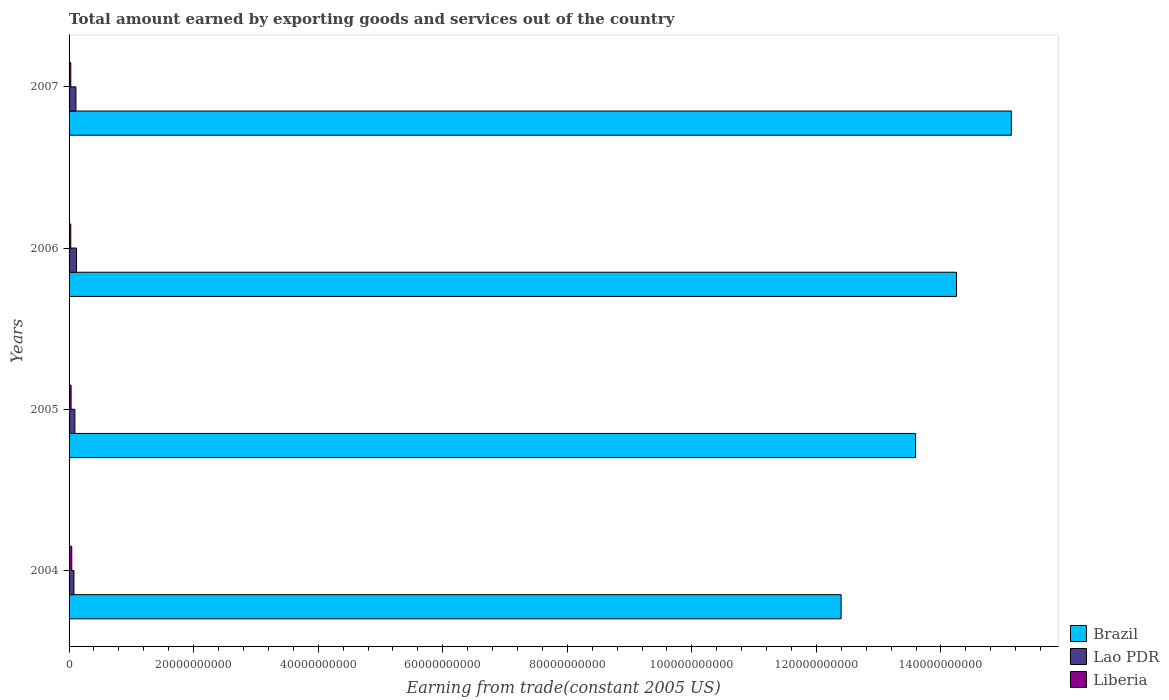How many groups of bars are there?
Your answer should be compact. 4. Are the number of bars per tick equal to the number of legend labels?
Offer a very short reply. Yes. Are the number of bars on each tick of the Y-axis equal?
Your answer should be very brief. Yes. How many bars are there on the 3rd tick from the top?
Offer a very short reply. 3. How many bars are there on the 3rd tick from the bottom?
Your answer should be compact. 3. In how many cases, is the number of bars for a given year not equal to the number of legend labels?
Your answer should be very brief. 0. What is the total amount earned by exporting goods and services in Liberia in 2006?
Offer a terse response. 2.71e+08. Across all years, what is the maximum total amount earned by exporting goods and services in Liberia?
Your answer should be very brief. 4.31e+08. Across all years, what is the minimum total amount earned by exporting goods and services in Brazil?
Your answer should be very brief. 1.24e+11. In which year was the total amount earned by exporting goods and services in Lao PDR maximum?
Your answer should be compact. 2006. In which year was the total amount earned by exporting goods and services in Lao PDR minimum?
Your answer should be very brief. 2004. What is the total total amount earned by exporting goods and services in Liberia in the graph?
Keep it short and to the point. 1.30e+09. What is the difference between the total amount earned by exporting goods and services in Lao PDR in 2004 and that in 2005?
Give a very brief answer. -1.54e+08. What is the difference between the total amount earned by exporting goods and services in Brazil in 2006 and the total amount earned by exporting goods and services in Liberia in 2007?
Keep it short and to the point. 1.42e+11. What is the average total amount earned by exporting goods and services in Lao PDR per year?
Ensure brevity in your answer.  1.00e+09. In the year 2007, what is the difference between the total amount earned by exporting goods and services in Brazil and total amount earned by exporting goods and services in Liberia?
Keep it short and to the point. 1.51e+11. What is the ratio of the total amount earned by exporting goods and services in Brazil in 2005 to that in 2007?
Provide a succinct answer. 0.9. Is the difference between the total amount earned by exporting goods and services in Brazil in 2004 and 2006 greater than the difference between the total amount earned by exporting goods and services in Liberia in 2004 and 2006?
Ensure brevity in your answer.  No. What is the difference between the highest and the second highest total amount earned by exporting goods and services in Brazil?
Your answer should be compact. 8.80e+09. What is the difference between the highest and the lowest total amount earned by exporting goods and services in Brazil?
Offer a very short reply. 2.73e+1. Is the sum of the total amount earned by exporting goods and services in Liberia in 2004 and 2005 greater than the maximum total amount earned by exporting goods and services in Brazil across all years?
Your answer should be compact. No. What does the 2nd bar from the top in 2007 represents?
Keep it short and to the point. Lao PDR. How many bars are there?
Your answer should be very brief. 12. Are all the bars in the graph horizontal?
Offer a very short reply. Yes. What is the difference between two consecutive major ticks on the X-axis?
Give a very brief answer. 2.00e+1. Does the graph contain any zero values?
Ensure brevity in your answer.  No. How many legend labels are there?
Your answer should be very brief. 3. What is the title of the graph?
Provide a succinct answer. Total amount earned by exporting goods and services out of the country. What is the label or title of the X-axis?
Make the answer very short. Earning from trade(constant 2005 US). What is the Earning from trade(constant 2005 US) in Brazil in 2004?
Offer a very short reply. 1.24e+11. What is the Earning from trade(constant 2005 US) of Lao PDR in 2004?
Your answer should be compact. 7.80e+08. What is the Earning from trade(constant 2005 US) in Liberia in 2004?
Make the answer very short. 4.31e+08. What is the Earning from trade(constant 2005 US) of Brazil in 2005?
Make the answer very short. 1.36e+11. What is the Earning from trade(constant 2005 US) of Lao PDR in 2005?
Your answer should be compact. 9.34e+08. What is the Earning from trade(constant 2005 US) of Liberia in 2005?
Your answer should be compact. 3.25e+08. What is the Earning from trade(constant 2005 US) of Brazil in 2006?
Your answer should be compact. 1.42e+11. What is the Earning from trade(constant 2005 US) of Lao PDR in 2006?
Give a very brief answer. 1.20e+09. What is the Earning from trade(constant 2005 US) in Liberia in 2006?
Your response must be concise. 2.71e+08. What is the Earning from trade(constant 2005 US) in Brazil in 2007?
Provide a short and direct response. 1.51e+11. What is the Earning from trade(constant 2005 US) of Lao PDR in 2007?
Offer a terse response. 1.10e+09. What is the Earning from trade(constant 2005 US) in Liberia in 2007?
Provide a succinct answer. 2.75e+08. Across all years, what is the maximum Earning from trade(constant 2005 US) in Brazil?
Make the answer very short. 1.51e+11. Across all years, what is the maximum Earning from trade(constant 2005 US) of Lao PDR?
Provide a succinct answer. 1.20e+09. Across all years, what is the maximum Earning from trade(constant 2005 US) of Liberia?
Your answer should be very brief. 4.31e+08. Across all years, what is the minimum Earning from trade(constant 2005 US) of Brazil?
Your answer should be compact. 1.24e+11. Across all years, what is the minimum Earning from trade(constant 2005 US) in Lao PDR?
Ensure brevity in your answer.  7.80e+08. Across all years, what is the minimum Earning from trade(constant 2005 US) of Liberia?
Offer a very short reply. 2.71e+08. What is the total Earning from trade(constant 2005 US) in Brazil in the graph?
Make the answer very short. 5.54e+11. What is the total Earning from trade(constant 2005 US) in Lao PDR in the graph?
Provide a succinct answer. 4.02e+09. What is the total Earning from trade(constant 2005 US) in Liberia in the graph?
Your answer should be very brief. 1.30e+09. What is the difference between the Earning from trade(constant 2005 US) of Brazil in 2004 and that in 2005?
Offer a very short reply. -1.20e+1. What is the difference between the Earning from trade(constant 2005 US) in Lao PDR in 2004 and that in 2005?
Offer a very short reply. -1.54e+08. What is the difference between the Earning from trade(constant 2005 US) in Liberia in 2004 and that in 2005?
Keep it short and to the point. 1.06e+08. What is the difference between the Earning from trade(constant 2005 US) in Brazil in 2004 and that in 2006?
Provide a succinct answer. -1.85e+1. What is the difference between the Earning from trade(constant 2005 US) in Lao PDR in 2004 and that in 2006?
Your answer should be very brief. -4.20e+08. What is the difference between the Earning from trade(constant 2005 US) of Liberia in 2004 and that in 2006?
Offer a terse response. 1.60e+08. What is the difference between the Earning from trade(constant 2005 US) in Brazil in 2004 and that in 2007?
Keep it short and to the point. -2.73e+1. What is the difference between the Earning from trade(constant 2005 US) of Lao PDR in 2004 and that in 2007?
Provide a succinct answer. -3.23e+08. What is the difference between the Earning from trade(constant 2005 US) in Liberia in 2004 and that in 2007?
Make the answer very short. 1.56e+08. What is the difference between the Earning from trade(constant 2005 US) in Brazil in 2005 and that in 2006?
Your answer should be very brief. -6.57e+09. What is the difference between the Earning from trade(constant 2005 US) of Lao PDR in 2005 and that in 2006?
Make the answer very short. -2.66e+08. What is the difference between the Earning from trade(constant 2005 US) in Liberia in 2005 and that in 2006?
Your answer should be very brief. 5.38e+07. What is the difference between the Earning from trade(constant 2005 US) in Brazil in 2005 and that in 2007?
Provide a succinct answer. -1.54e+1. What is the difference between the Earning from trade(constant 2005 US) of Lao PDR in 2005 and that in 2007?
Your answer should be compact. -1.69e+08. What is the difference between the Earning from trade(constant 2005 US) of Liberia in 2005 and that in 2007?
Offer a very short reply. 5.02e+07. What is the difference between the Earning from trade(constant 2005 US) in Brazil in 2006 and that in 2007?
Ensure brevity in your answer.  -8.80e+09. What is the difference between the Earning from trade(constant 2005 US) of Lao PDR in 2006 and that in 2007?
Ensure brevity in your answer.  9.74e+07. What is the difference between the Earning from trade(constant 2005 US) of Liberia in 2006 and that in 2007?
Make the answer very short. -3.59e+06. What is the difference between the Earning from trade(constant 2005 US) of Brazil in 2004 and the Earning from trade(constant 2005 US) of Lao PDR in 2005?
Provide a succinct answer. 1.23e+11. What is the difference between the Earning from trade(constant 2005 US) in Brazil in 2004 and the Earning from trade(constant 2005 US) in Liberia in 2005?
Keep it short and to the point. 1.24e+11. What is the difference between the Earning from trade(constant 2005 US) in Lao PDR in 2004 and the Earning from trade(constant 2005 US) in Liberia in 2005?
Your answer should be very brief. 4.55e+08. What is the difference between the Earning from trade(constant 2005 US) of Brazil in 2004 and the Earning from trade(constant 2005 US) of Lao PDR in 2006?
Your response must be concise. 1.23e+11. What is the difference between the Earning from trade(constant 2005 US) of Brazil in 2004 and the Earning from trade(constant 2005 US) of Liberia in 2006?
Give a very brief answer. 1.24e+11. What is the difference between the Earning from trade(constant 2005 US) of Lao PDR in 2004 and the Earning from trade(constant 2005 US) of Liberia in 2006?
Make the answer very short. 5.09e+08. What is the difference between the Earning from trade(constant 2005 US) in Brazil in 2004 and the Earning from trade(constant 2005 US) in Lao PDR in 2007?
Keep it short and to the point. 1.23e+11. What is the difference between the Earning from trade(constant 2005 US) in Brazil in 2004 and the Earning from trade(constant 2005 US) in Liberia in 2007?
Offer a terse response. 1.24e+11. What is the difference between the Earning from trade(constant 2005 US) of Lao PDR in 2004 and the Earning from trade(constant 2005 US) of Liberia in 2007?
Your response must be concise. 5.06e+08. What is the difference between the Earning from trade(constant 2005 US) in Brazil in 2005 and the Earning from trade(constant 2005 US) in Lao PDR in 2006?
Your answer should be compact. 1.35e+11. What is the difference between the Earning from trade(constant 2005 US) of Brazil in 2005 and the Earning from trade(constant 2005 US) of Liberia in 2006?
Ensure brevity in your answer.  1.36e+11. What is the difference between the Earning from trade(constant 2005 US) of Lao PDR in 2005 and the Earning from trade(constant 2005 US) of Liberia in 2006?
Offer a very short reply. 6.63e+08. What is the difference between the Earning from trade(constant 2005 US) of Brazil in 2005 and the Earning from trade(constant 2005 US) of Lao PDR in 2007?
Your response must be concise. 1.35e+11. What is the difference between the Earning from trade(constant 2005 US) of Brazil in 2005 and the Earning from trade(constant 2005 US) of Liberia in 2007?
Your answer should be very brief. 1.36e+11. What is the difference between the Earning from trade(constant 2005 US) of Lao PDR in 2005 and the Earning from trade(constant 2005 US) of Liberia in 2007?
Your response must be concise. 6.60e+08. What is the difference between the Earning from trade(constant 2005 US) of Brazil in 2006 and the Earning from trade(constant 2005 US) of Lao PDR in 2007?
Offer a terse response. 1.41e+11. What is the difference between the Earning from trade(constant 2005 US) in Brazil in 2006 and the Earning from trade(constant 2005 US) in Liberia in 2007?
Offer a very short reply. 1.42e+11. What is the difference between the Earning from trade(constant 2005 US) of Lao PDR in 2006 and the Earning from trade(constant 2005 US) of Liberia in 2007?
Your answer should be very brief. 9.26e+08. What is the average Earning from trade(constant 2005 US) of Brazil per year?
Your response must be concise. 1.38e+11. What is the average Earning from trade(constant 2005 US) in Lao PDR per year?
Provide a short and direct response. 1.00e+09. What is the average Earning from trade(constant 2005 US) in Liberia per year?
Your response must be concise. 3.25e+08. In the year 2004, what is the difference between the Earning from trade(constant 2005 US) in Brazil and Earning from trade(constant 2005 US) in Lao PDR?
Your answer should be compact. 1.23e+11. In the year 2004, what is the difference between the Earning from trade(constant 2005 US) in Brazil and Earning from trade(constant 2005 US) in Liberia?
Provide a succinct answer. 1.24e+11. In the year 2004, what is the difference between the Earning from trade(constant 2005 US) in Lao PDR and Earning from trade(constant 2005 US) in Liberia?
Make the answer very short. 3.50e+08. In the year 2005, what is the difference between the Earning from trade(constant 2005 US) in Brazil and Earning from trade(constant 2005 US) in Lao PDR?
Make the answer very short. 1.35e+11. In the year 2005, what is the difference between the Earning from trade(constant 2005 US) of Brazil and Earning from trade(constant 2005 US) of Liberia?
Make the answer very short. 1.36e+11. In the year 2005, what is the difference between the Earning from trade(constant 2005 US) of Lao PDR and Earning from trade(constant 2005 US) of Liberia?
Offer a very short reply. 6.09e+08. In the year 2006, what is the difference between the Earning from trade(constant 2005 US) in Brazil and Earning from trade(constant 2005 US) in Lao PDR?
Provide a succinct answer. 1.41e+11. In the year 2006, what is the difference between the Earning from trade(constant 2005 US) in Brazil and Earning from trade(constant 2005 US) in Liberia?
Your answer should be very brief. 1.42e+11. In the year 2006, what is the difference between the Earning from trade(constant 2005 US) in Lao PDR and Earning from trade(constant 2005 US) in Liberia?
Your response must be concise. 9.29e+08. In the year 2007, what is the difference between the Earning from trade(constant 2005 US) of Brazil and Earning from trade(constant 2005 US) of Lao PDR?
Your response must be concise. 1.50e+11. In the year 2007, what is the difference between the Earning from trade(constant 2005 US) in Brazil and Earning from trade(constant 2005 US) in Liberia?
Offer a very short reply. 1.51e+11. In the year 2007, what is the difference between the Earning from trade(constant 2005 US) of Lao PDR and Earning from trade(constant 2005 US) of Liberia?
Your answer should be very brief. 8.28e+08. What is the ratio of the Earning from trade(constant 2005 US) in Brazil in 2004 to that in 2005?
Your answer should be compact. 0.91. What is the ratio of the Earning from trade(constant 2005 US) of Lao PDR in 2004 to that in 2005?
Your answer should be compact. 0.84. What is the ratio of the Earning from trade(constant 2005 US) of Liberia in 2004 to that in 2005?
Offer a terse response. 1.33. What is the ratio of the Earning from trade(constant 2005 US) in Brazil in 2004 to that in 2006?
Ensure brevity in your answer.  0.87. What is the ratio of the Earning from trade(constant 2005 US) in Lao PDR in 2004 to that in 2006?
Your response must be concise. 0.65. What is the ratio of the Earning from trade(constant 2005 US) in Liberia in 2004 to that in 2006?
Provide a succinct answer. 1.59. What is the ratio of the Earning from trade(constant 2005 US) of Brazil in 2004 to that in 2007?
Ensure brevity in your answer.  0.82. What is the ratio of the Earning from trade(constant 2005 US) of Lao PDR in 2004 to that in 2007?
Keep it short and to the point. 0.71. What is the ratio of the Earning from trade(constant 2005 US) of Liberia in 2004 to that in 2007?
Keep it short and to the point. 1.57. What is the ratio of the Earning from trade(constant 2005 US) of Brazil in 2005 to that in 2006?
Your answer should be compact. 0.95. What is the ratio of the Earning from trade(constant 2005 US) of Lao PDR in 2005 to that in 2006?
Provide a short and direct response. 0.78. What is the ratio of the Earning from trade(constant 2005 US) of Liberia in 2005 to that in 2006?
Provide a short and direct response. 1.2. What is the ratio of the Earning from trade(constant 2005 US) in Brazil in 2005 to that in 2007?
Offer a very short reply. 0.9. What is the ratio of the Earning from trade(constant 2005 US) in Lao PDR in 2005 to that in 2007?
Provide a short and direct response. 0.85. What is the ratio of the Earning from trade(constant 2005 US) of Liberia in 2005 to that in 2007?
Your answer should be very brief. 1.18. What is the ratio of the Earning from trade(constant 2005 US) in Brazil in 2006 to that in 2007?
Offer a terse response. 0.94. What is the ratio of the Earning from trade(constant 2005 US) in Lao PDR in 2006 to that in 2007?
Provide a short and direct response. 1.09. What is the ratio of the Earning from trade(constant 2005 US) in Liberia in 2006 to that in 2007?
Offer a very short reply. 0.99. What is the difference between the highest and the second highest Earning from trade(constant 2005 US) in Brazil?
Ensure brevity in your answer.  8.80e+09. What is the difference between the highest and the second highest Earning from trade(constant 2005 US) in Lao PDR?
Make the answer very short. 9.74e+07. What is the difference between the highest and the second highest Earning from trade(constant 2005 US) of Liberia?
Your response must be concise. 1.06e+08. What is the difference between the highest and the lowest Earning from trade(constant 2005 US) of Brazil?
Your response must be concise. 2.73e+1. What is the difference between the highest and the lowest Earning from trade(constant 2005 US) of Lao PDR?
Your answer should be very brief. 4.20e+08. What is the difference between the highest and the lowest Earning from trade(constant 2005 US) of Liberia?
Provide a succinct answer. 1.60e+08. 